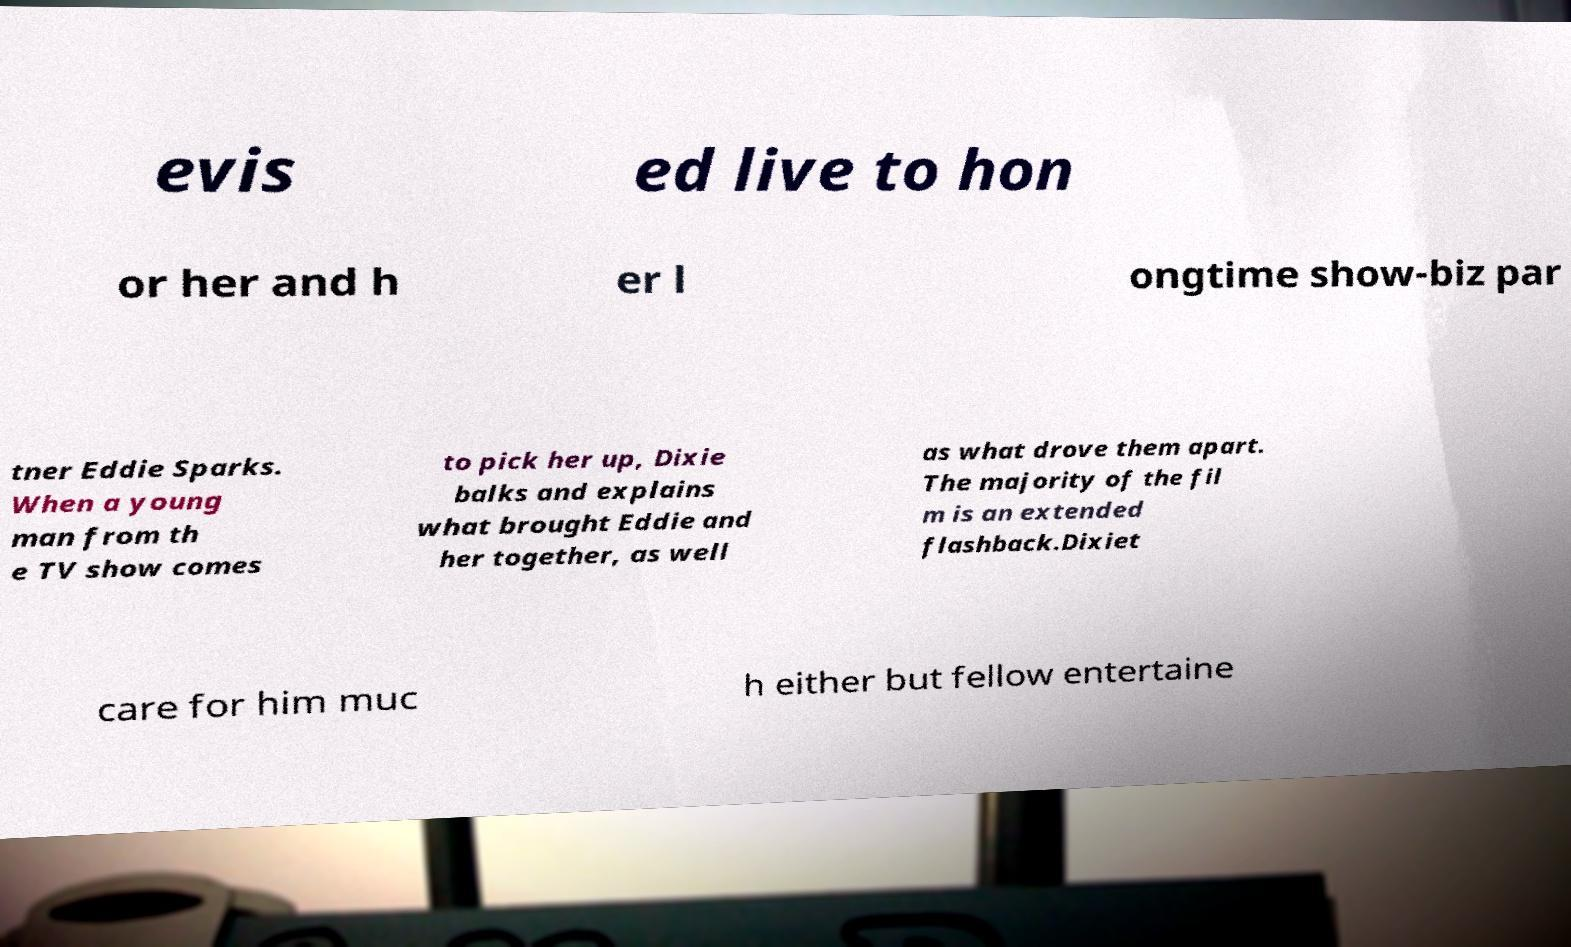Can you read and provide the text displayed in the image?This photo seems to have some interesting text. Can you extract and type it out for me? evis ed live to hon or her and h er l ongtime show-biz par tner Eddie Sparks. When a young man from th e TV show comes to pick her up, Dixie balks and explains what brought Eddie and her together, as well as what drove them apart. The majority of the fil m is an extended flashback.Dixiet care for him muc h either but fellow entertaine 